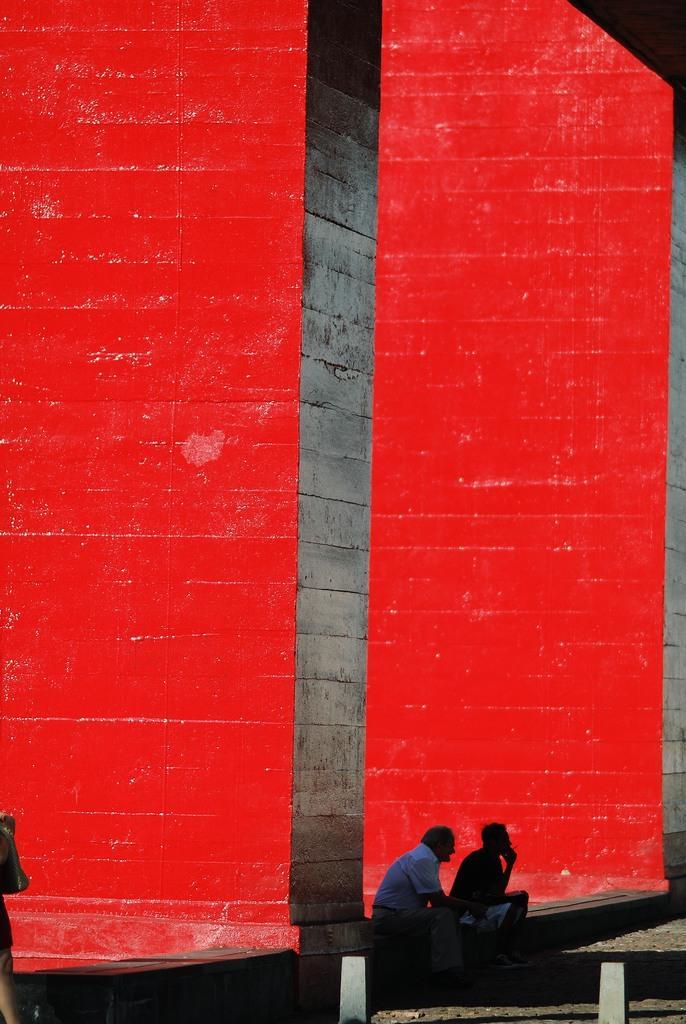Describe this image in one or two sentences. In the foreground of this image, there are two men sitting on the stone surface. We can also see two bollards and a person on the left. Behind them, there is a red wall and also the stone surface of the wall. 